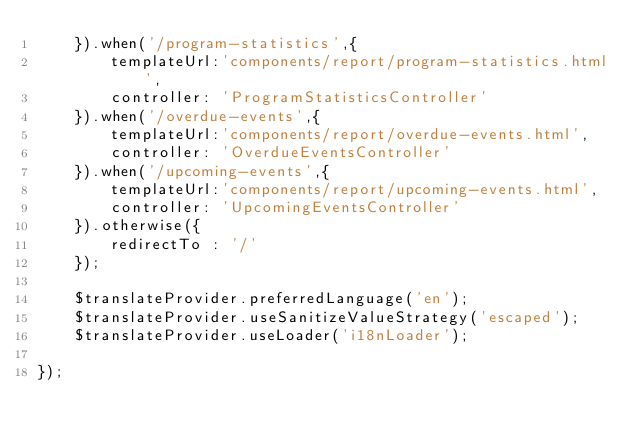Convert code to text. <code><loc_0><loc_0><loc_500><loc_500><_JavaScript_>    }).when('/program-statistics',{
        templateUrl:'components/report/program-statistics.html',
        controller: 'ProgramStatisticsController'
    }).when('/overdue-events',{
        templateUrl:'components/report/overdue-events.html',
        controller: 'OverdueEventsController'
    }).when('/upcoming-events',{
        templateUrl:'components/report/upcoming-events.html',
        controller: 'UpcomingEventsController'
    }).otherwise({
        redirectTo : '/'
    });  
    
    $translateProvider.preferredLanguage('en');
    $translateProvider.useSanitizeValueStrategy('escaped');
    $translateProvider.useLoader('i18nLoader');
    
});</code> 